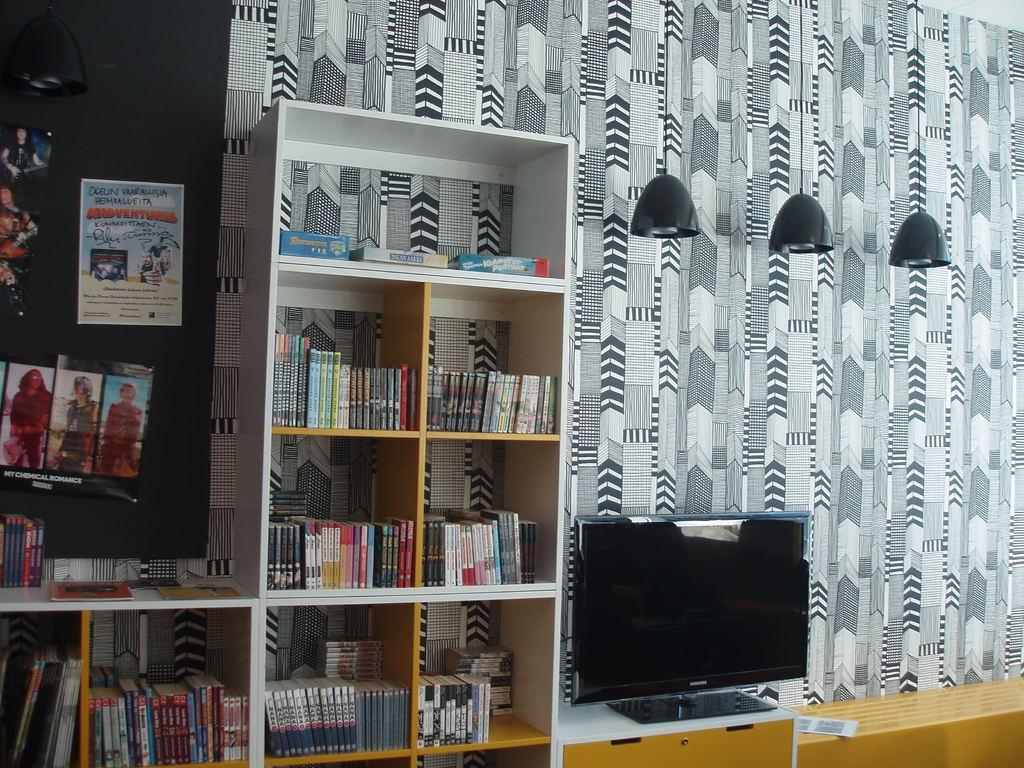What type of items can be seen in the racks in the image? There are books in the racks in the image. What is the main object located in the middle of the image? There is a TV in the middle of the image. What type of illumination is present at the top of the image? There are lights at the top of the image. Can you see the thumb of the person who placed the books on the rack in the image? There is no person or thumb visible in the image; it only shows books in the racks, a TV in the middle, and lights at the top. What type of motion is happening in the image? There is no motion visible in the image; it is a still picture. 